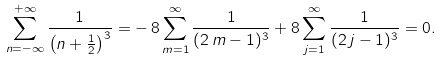<formula> <loc_0><loc_0><loc_500><loc_500>\sum _ { n = - \infty } ^ { + \infty } { \frac { 1 } { \left ( n + \frac { 1 } { 2 } \right ) ^ { 3 } } } = - \, 8 \sum _ { m = 1 } ^ { \infty } { \frac { 1 } { ( 2 \, m - 1 ) ^ { 3 } } } + 8 \sum _ { j = 1 } ^ { \infty } { \frac { 1 } { ( 2 \, j - 1 ) ^ { 3 } } } = 0 .</formula> 